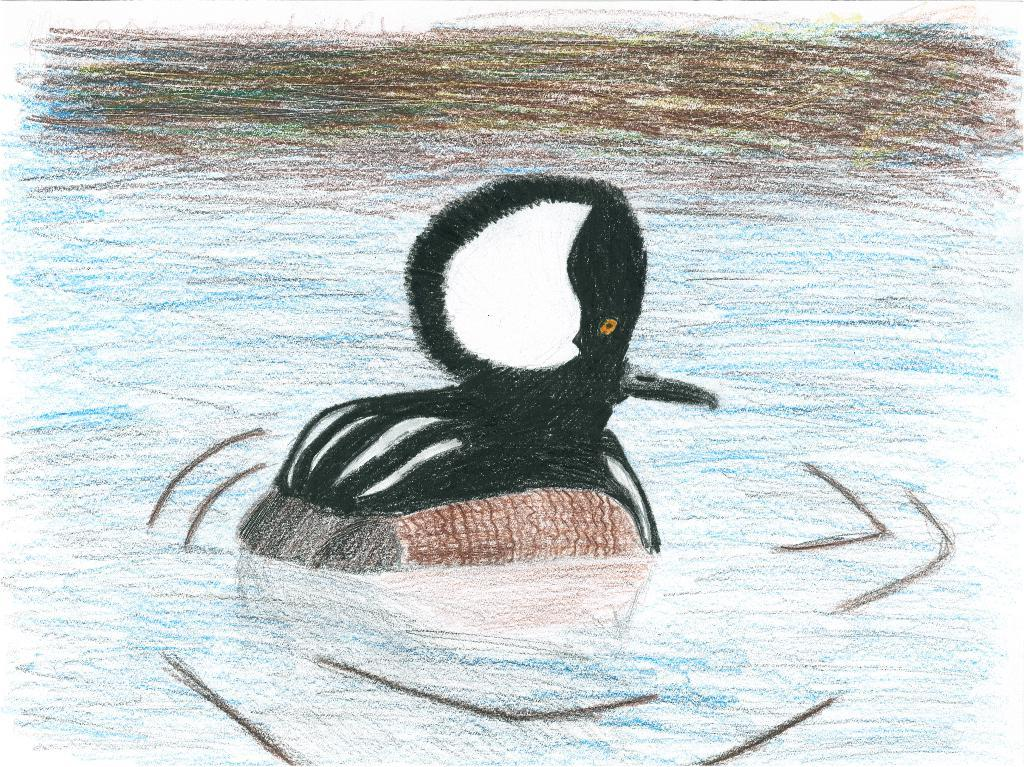What is the main subject of the image? There is a painting in the image. What is depicted in the painting? The painting depicts an animal. Where is the animal located in the painting? The animal is in the water. What type of impulse can be seen affecting the animal in the painting? There is no mention of an impulse affecting the animal in the painting; it is simply depicted as being in the water. 